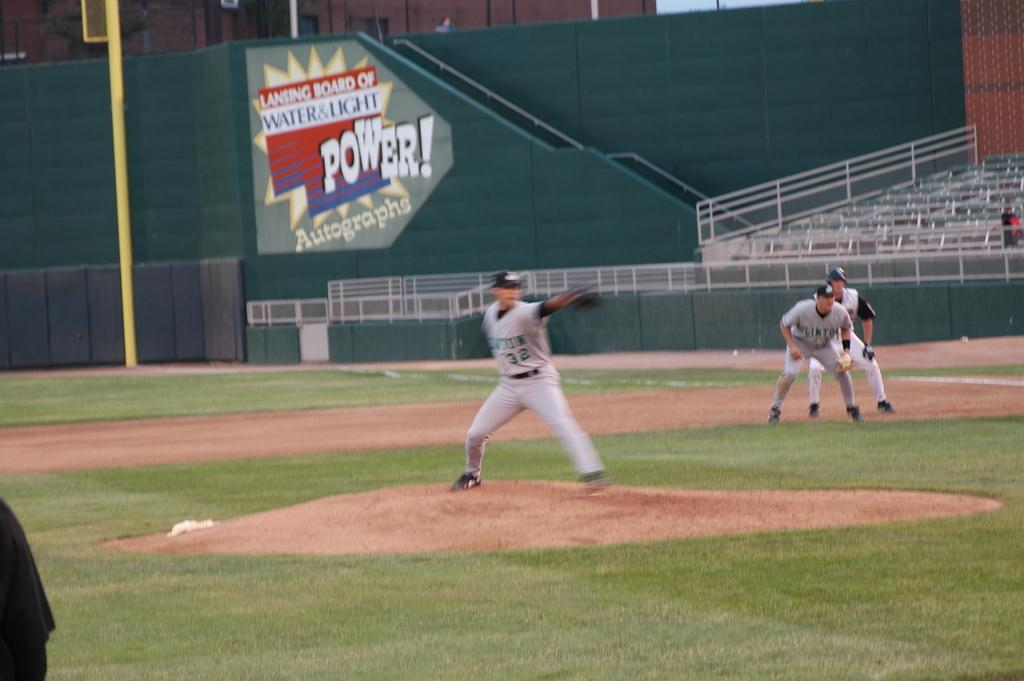Provide a one-sentence caption for the provided image. a pitcher with the number 32 on his jersey. 